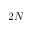Convert formula to latex. <formula><loc_0><loc_0><loc_500><loc_500>2 N</formula> 